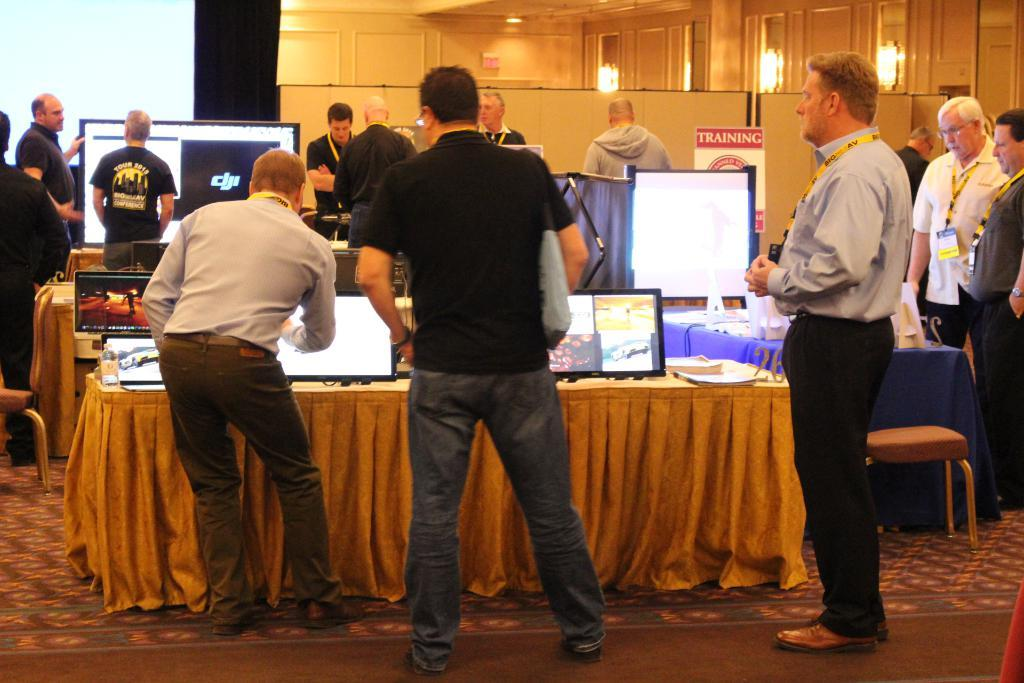What are the people in the image doing? The people in the image are standing in front of tables. What can be seen on the tables? Monitors are present on the tables, along with other objects. What is visible in the background of the image? There is a wall in the background of the image. What type of cheese is being pushed on the tables in the image? There is no cheese present in the image, and no pushing is taking place. 